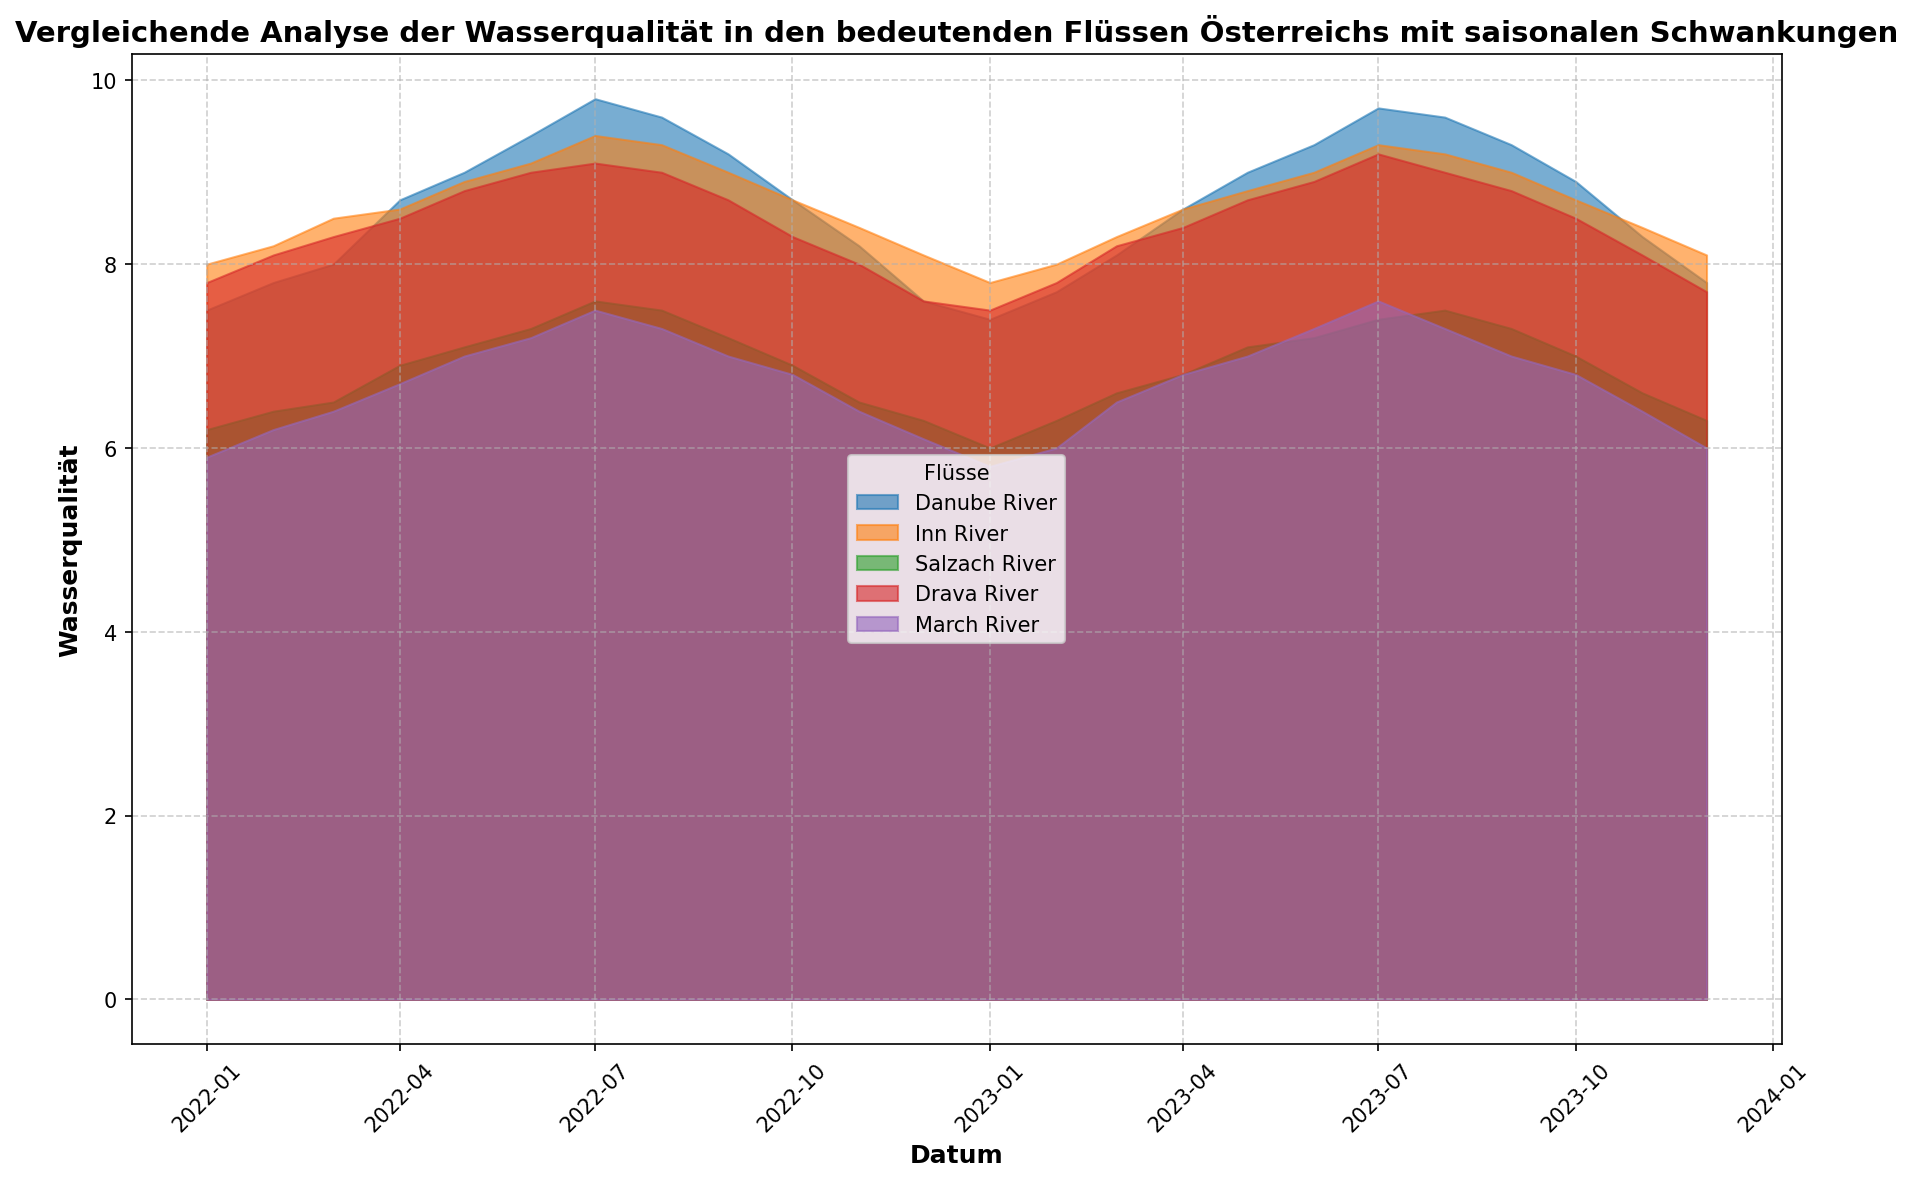Was ist der Durchschnitt der Wasserqualität im Drava River im Jahr 2022? Zuerst addieren wir alle monatlichen Werte für 2022: 7.8 + 8.1 + 8.3 + 8.5 + 8.8 + 9.0 + 9.1 + 9.0 + 8.7 + 8.3 + 8.0 + 7.6 = 102.2. Dann teilen wir diese Summe durch 12 (Monate): 102.2 / 12 = 8.52
Answer: 8.52 Welche beiden Flüsse haben die höchsten Wasserqualitätswerte im Sommer (Juni bis August) 2023? Betrachten wir die Werte für Juni, Juli und August 2023: Salzach River hat die Werte 7.5, 7.4, 7.5, was niedriger ist als die anderen Flüsse. Die höchsten Werte haben Danube River (9.6, 9.7, 9.6) und Inn River (9.0, 9.3, 9.2).
Answer: Danube River und Inn River Wie unterscheidet sich die Wasserqualität des March River im Januar 2022 und Januar 2023? Der Wert für Januar 2022 ist 5.9 und für Januar 2023 ist 5.8. Der Unterschied ist 5.9 - 5.8 = 0.1.
Answer: 0.1 Welcher Monat hat die höchste Wasserqualität im Salzach River in 2023? Wir betrachten die Werte für 2023: 6.0 (Jan), 6.3 (Feb), 6.6 (Mar), 6.8 (Apr), 7.1 (May), 7.2 (Jun), 7.4 (Jul), 7.5 (Aug), 7.3 (Sep), 7.0 (Oct), 6.6 (Nov), 6.3 (Dec). Der höchste Wert ist 7.5 im August
Answer: August Zwischen März und April 2023: in welchem Fluss steigt die Wasserqualität am stärksten? Wir vergleichen die Differenzen: Danube River (8.1-8.6= -0.5), Inn River (8.3-8.6= -0.3), Salzach River (6.6-6.8= -0.2), Drava River (8.2-8.4= -0.2), March River (6.5-6.8= -0.3). Die Wasserqualität des March River steigt von 8.1 (März) auf 8.6 (April), was den größten Anstieg darstellt.
Answer: March River Im welchen Monat ist die Wasserqualität des Inn River am niedrigsten in 2022? Vergleichen wir die Werte für 2022: Januar (8.0), Februar (8.2), März (8.5), April (8.6), Mai (8.9), Juni (9.1), Juli (9.4), August (9.3), September (9.0), Oktober (8.7), November (8.4), Dezember (8.1). Der niedrigste Wert ist 8.0 im Januar.
Answer: Januar Welcher Fluss zeigt die größte saisonale Schwankung der Wasserqualität von 2022 bis 2023? Um die saisonale Schwankung zu bestimmen, wird die Differenz zwischen dem höchsten und niedrigsten Wert jedes Flusses betrachtet: Danube River: 9.8 - 7.4 = 2.4, Inn River: 9.4 - 7.8 = 1.6, Salzach River: 7.6 - 6.0 = 1.6, Drava River: 9.2 - 7.5 = 1.7, March River: 7.6 - 5.8 = 1.8. Die größte saisonale Schwankung zeigt die Danube River mit 2.4.
Answer: Danube River 